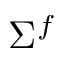<formula> <loc_0><loc_0><loc_500><loc_500>\Sigma ^ { f }</formula> 